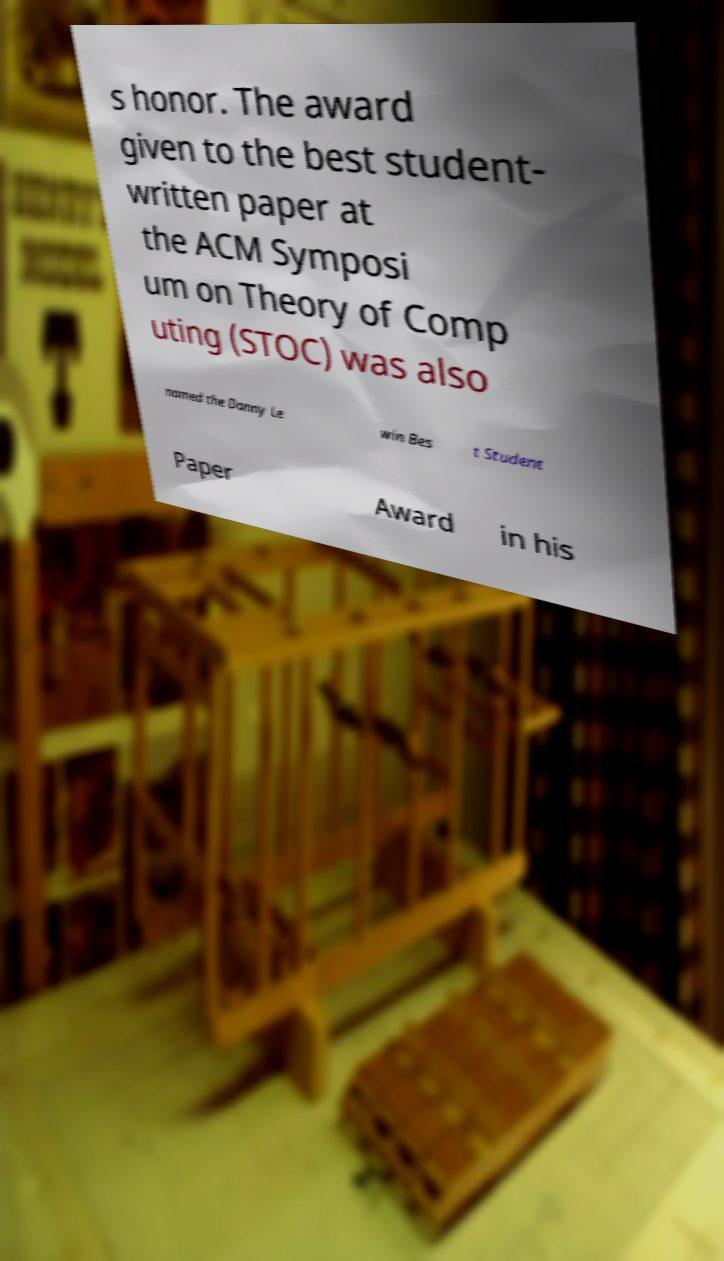For documentation purposes, I need the text within this image transcribed. Could you provide that? s honor. The award given to the best student- written paper at the ACM Symposi um on Theory of Comp uting (STOC) was also named the Danny Le win Bes t Student Paper Award in his 